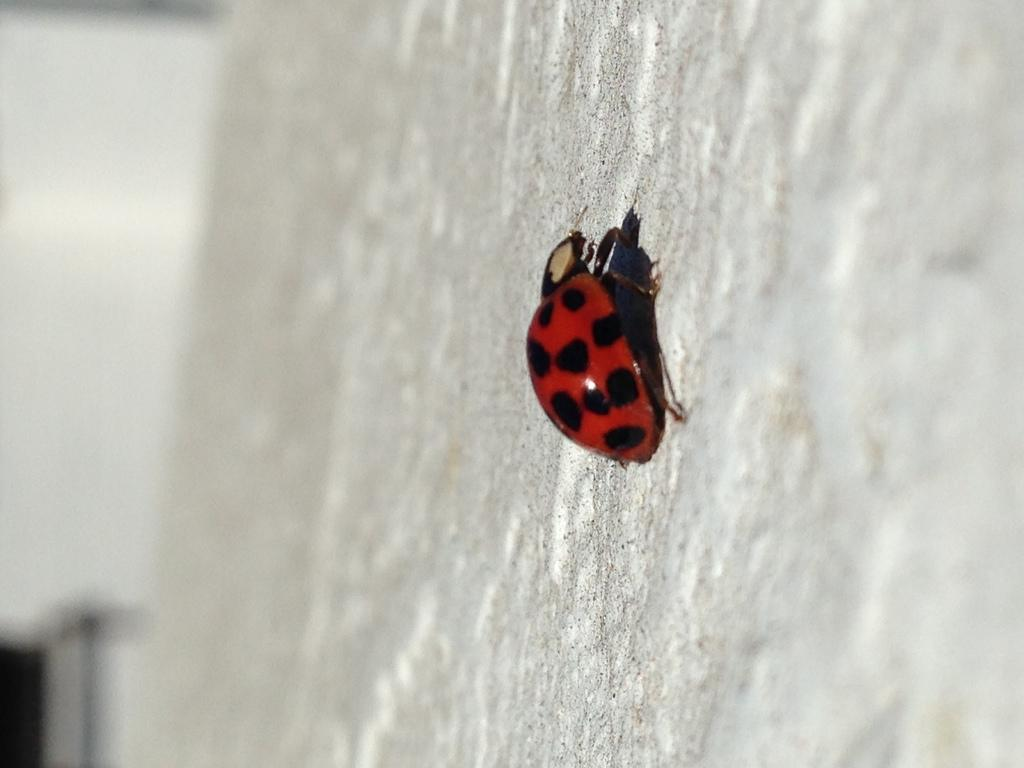What type of creature is present in the image? There is an insect in the image. Where is the insect located? The insect is on a wall. Is the insect feeding on blood in the image? There is no indication in the image that the insect is feeding on blood. 